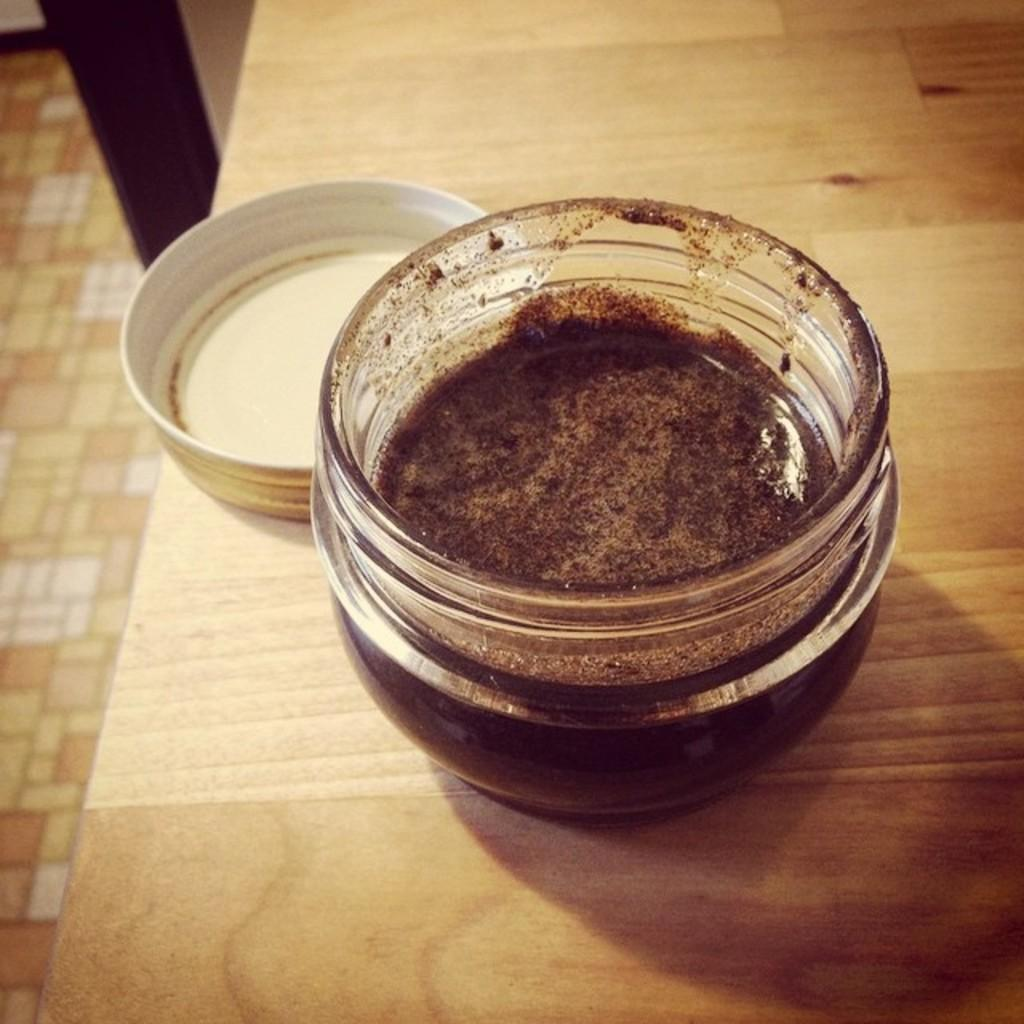What is in the bowl that is visible in the image? There is a food item in a bowl in the image. Where is the bowl located in the image? The bowl is on a table in the image. What object is beside the bowl on the table? There is a cap beside the bowl in the image. What can be seen below the table in the image? The floor is visible in the image. Can you see a snail crawling on the floor in the image? There is no snail visible on the floor in the image. 